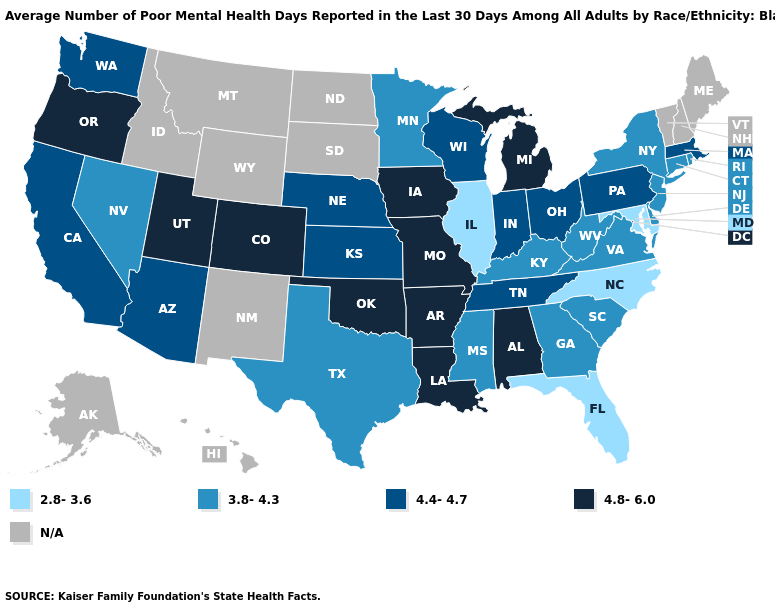Does the first symbol in the legend represent the smallest category?
Quick response, please. Yes. Among the states that border Alabama , does Florida have the lowest value?
Short answer required. Yes. What is the value of New Hampshire?
Short answer required. N/A. Does Massachusetts have the lowest value in the Northeast?
Write a very short answer. No. Name the states that have a value in the range N/A?
Write a very short answer. Alaska, Hawaii, Idaho, Maine, Montana, New Hampshire, New Mexico, North Dakota, South Dakota, Vermont, Wyoming. What is the value of Wisconsin?
Quick response, please. 4.4-4.7. Name the states that have a value in the range 4.4-4.7?
Quick response, please. Arizona, California, Indiana, Kansas, Massachusetts, Nebraska, Ohio, Pennsylvania, Tennessee, Washington, Wisconsin. Name the states that have a value in the range 2.8-3.6?
Short answer required. Florida, Illinois, Maryland, North Carolina. Name the states that have a value in the range 4.4-4.7?
Write a very short answer. Arizona, California, Indiana, Kansas, Massachusetts, Nebraska, Ohio, Pennsylvania, Tennessee, Washington, Wisconsin. What is the value of Utah?
Write a very short answer. 4.8-6.0. Which states have the lowest value in the Northeast?
Give a very brief answer. Connecticut, New Jersey, New York, Rhode Island. Which states hav the highest value in the MidWest?
Short answer required. Iowa, Michigan, Missouri. Does the map have missing data?
Quick response, please. Yes. Name the states that have a value in the range 3.8-4.3?
Short answer required. Connecticut, Delaware, Georgia, Kentucky, Minnesota, Mississippi, Nevada, New Jersey, New York, Rhode Island, South Carolina, Texas, Virginia, West Virginia. What is the value of Tennessee?
Keep it brief. 4.4-4.7. 